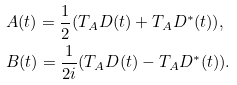Convert formula to latex. <formula><loc_0><loc_0><loc_500><loc_500>& A ( t ) = \frac { 1 } { 2 } ( T _ { A } D ( t ) + T _ { A } D ^ { \ast } ( t ) ) , \\ & B ( t ) = \frac { 1 } { 2 i } ( T _ { A } D ( t ) - T _ { A } D ^ { \ast } ( t ) ) .</formula> 